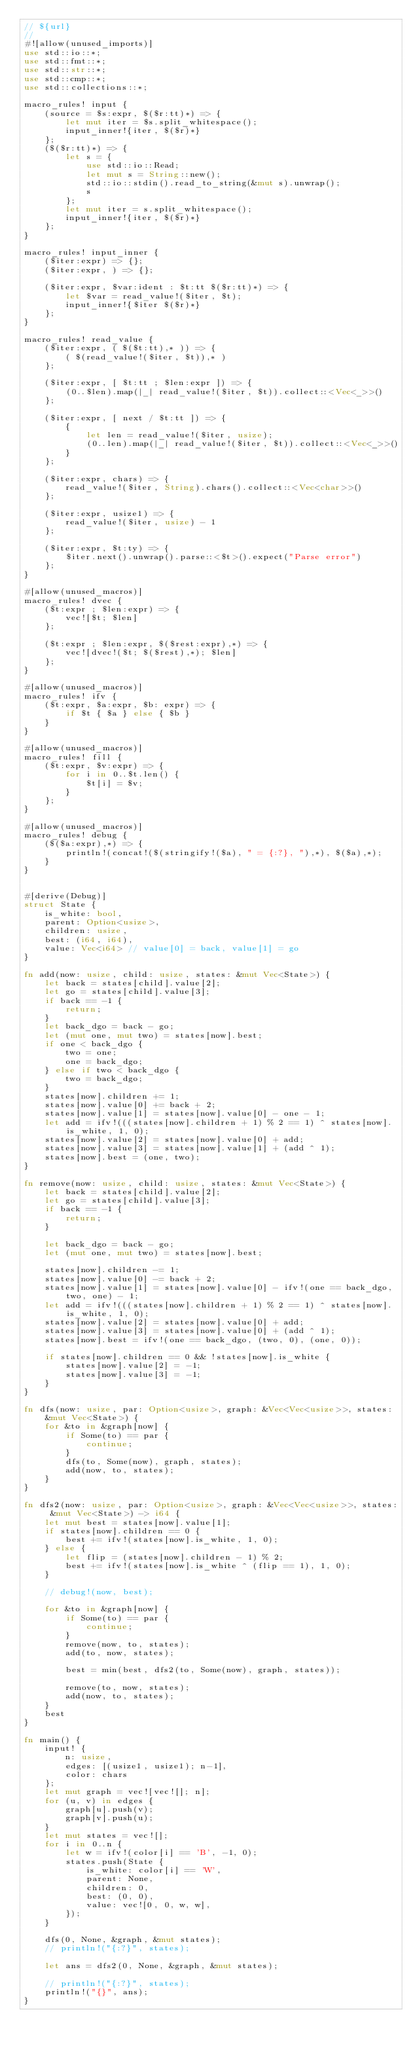<code> <loc_0><loc_0><loc_500><loc_500><_Rust_>// ${url}
//
#![allow(unused_imports)]
use std::io::*;
use std::fmt::*;
use std::str::*;
use std::cmp::*;
use std::collections::*;

macro_rules! input {
    (source = $s:expr, $($r:tt)*) => {
        let mut iter = $s.split_whitespace();
        input_inner!{iter, $($r)*}
    };
    ($($r:tt)*) => {
        let s = {
            use std::io::Read;
            let mut s = String::new();
            std::io::stdin().read_to_string(&mut s).unwrap();
            s
        };
        let mut iter = s.split_whitespace();
        input_inner!{iter, $($r)*}
    };
}

macro_rules! input_inner {
    ($iter:expr) => {};
    ($iter:expr, ) => {};

    ($iter:expr, $var:ident : $t:tt $($r:tt)*) => {
        let $var = read_value!($iter, $t);
        input_inner!{$iter $($r)*}
    };
}

macro_rules! read_value {
    ($iter:expr, ( $($t:tt),* )) => {
        ( $(read_value!($iter, $t)),* )
    };

    ($iter:expr, [ $t:tt ; $len:expr ]) => {
        (0..$len).map(|_| read_value!($iter, $t)).collect::<Vec<_>>()
    };

    ($iter:expr, [ next / $t:tt ]) => {
        {
            let len = read_value!($iter, usize);
            (0..len).map(|_| read_value!($iter, $t)).collect::<Vec<_>>()
        }
    };

    ($iter:expr, chars) => {
        read_value!($iter, String).chars().collect::<Vec<char>>()
    };

    ($iter:expr, usize1) => {
        read_value!($iter, usize) - 1
    };

    ($iter:expr, $t:ty) => {
        $iter.next().unwrap().parse::<$t>().expect("Parse error")
    };
}

#[allow(unused_macros)]
macro_rules! dvec {
    ($t:expr ; $len:expr) => {
        vec![$t; $len]
    };

    ($t:expr ; $len:expr, $($rest:expr),*) => {
        vec![dvec!($t; $($rest),*); $len]
    };
}

#[allow(unused_macros)]
macro_rules! ifv {
    ($t:expr, $a:expr, $b: expr) => {
        if $t { $a } else { $b }
    }
}

#[allow(unused_macros)]
macro_rules! fill {
    ($t:expr, $v:expr) => {
        for i in 0..$t.len() {
            $t[i] = $v;
        }
    };
}

#[allow(unused_macros)]
macro_rules! debug {
    ($($a:expr),*) => {
        println!(concat!($(stringify!($a), " = {:?}, "),*), $($a),*);
    }
}


#[derive(Debug)]
struct State {
    is_white: bool,
    parent: Option<usize>,
    children: usize,
    best: (i64, i64),
    value: Vec<i64> // value[0] = back, value[1] = go
}

fn add(now: usize, child: usize, states: &mut Vec<State>) {
    let back = states[child].value[2];
    let go = states[child].value[3];
    if back == -1 {
        return;
    }
    let back_dgo = back - go;
    let (mut one, mut two) = states[now].best;
    if one < back_dgo {
        two = one;
        one = back_dgo;
    } else if two < back_dgo {
        two = back_dgo;
    }
    states[now].children += 1;
    states[now].value[0] += back + 2;
    states[now].value[1] = states[now].value[0] - one - 1;
    let add = ifv!(((states[now].children + 1) % 2 == 1) ^ states[now].is_white, 1, 0);
    states[now].value[2] = states[now].value[0] + add;
    states[now].value[3] = states[now].value[1] + (add ^ 1);
    states[now].best = (one, two);
}

fn remove(now: usize, child: usize, states: &mut Vec<State>) {
    let back = states[child].value[2];
    let go = states[child].value[3];
    if back == -1 {
        return;
    }

    let back_dgo = back - go;
    let (mut one, mut two) = states[now].best;

    states[now].children -= 1;
    states[now].value[0] -= back + 2;
    states[now].value[1] = states[now].value[0] - ifv!(one == back_dgo, two, one) - 1;
    let add = ifv!(((states[now].children + 1) % 2 == 1) ^ states[now].is_white, 1, 0);
    states[now].value[2] = states[now].value[0] + add;
    states[now].value[3] = states[now].value[0] + (add ^ 1);
    states[now].best = ifv!(one == back_dgo, (two, 0), (one, 0));

    if states[now].children == 0 && !states[now].is_white {
        states[now].value[2] = -1;
        states[now].value[3] = -1;
    }
}

fn dfs(now: usize, par: Option<usize>, graph: &Vec<Vec<usize>>, states: &mut Vec<State>) {
    for &to in &graph[now] {
        if Some(to) == par {
            continue;
        }
        dfs(to, Some(now), graph, states);
        add(now, to, states);
    }
}

fn dfs2(now: usize, par: Option<usize>, graph: &Vec<Vec<usize>>, states: &mut Vec<State>) -> i64 {
    let mut best = states[now].value[1];
    if states[now].children == 0 {
        best += ifv!(states[now].is_white, 1, 0);
    } else {
        let flip = (states[now].children - 1) % 2;
        best += ifv!(states[now].is_white ^ (flip == 1), 1, 0);
    }

    // debug!(now, best);

    for &to in &graph[now] {
        if Some(to) == par {
            continue;
        }
        remove(now, to, states);
        add(to, now, states);

        best = min(best, dfs2(to, Some(now), graph, states));

        remove(to, now, states);
        add(now, to, states);
    }
    best
}

fn main() {
    input! {
        n: usize,
        edges: [(usize1, usize1); n-1],
        color: chars
    };
    let mut graph = vec![vec![]; n];
    for (u, v) in edges {
        graph[u].push(v);
        graph[v].push(u);
    }
    let mut states = vec![];
    for i in 0..n {
        let w = ifv!(color[i] == 'B', -1, 0);
        states.push(State {
            is_white: color[i] == 'W',
            parent: None,
            children: 0,
            best: (0, 0),
            value: vec![0, 0, w, w],
        });
    }

    dfs(0, None, &graph, &mut states);
    // println!("{:?}", states);

    let ans = dfs2(0, None, &graph, &mut states);

    // println!("{:?}", states);
    println!("{}", ans);
}
</code> 